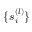<formula> <loc_0><loc_0><loc_500><loc_500>\{ s _ { i } ^ { ( l ) } \}</formula> 